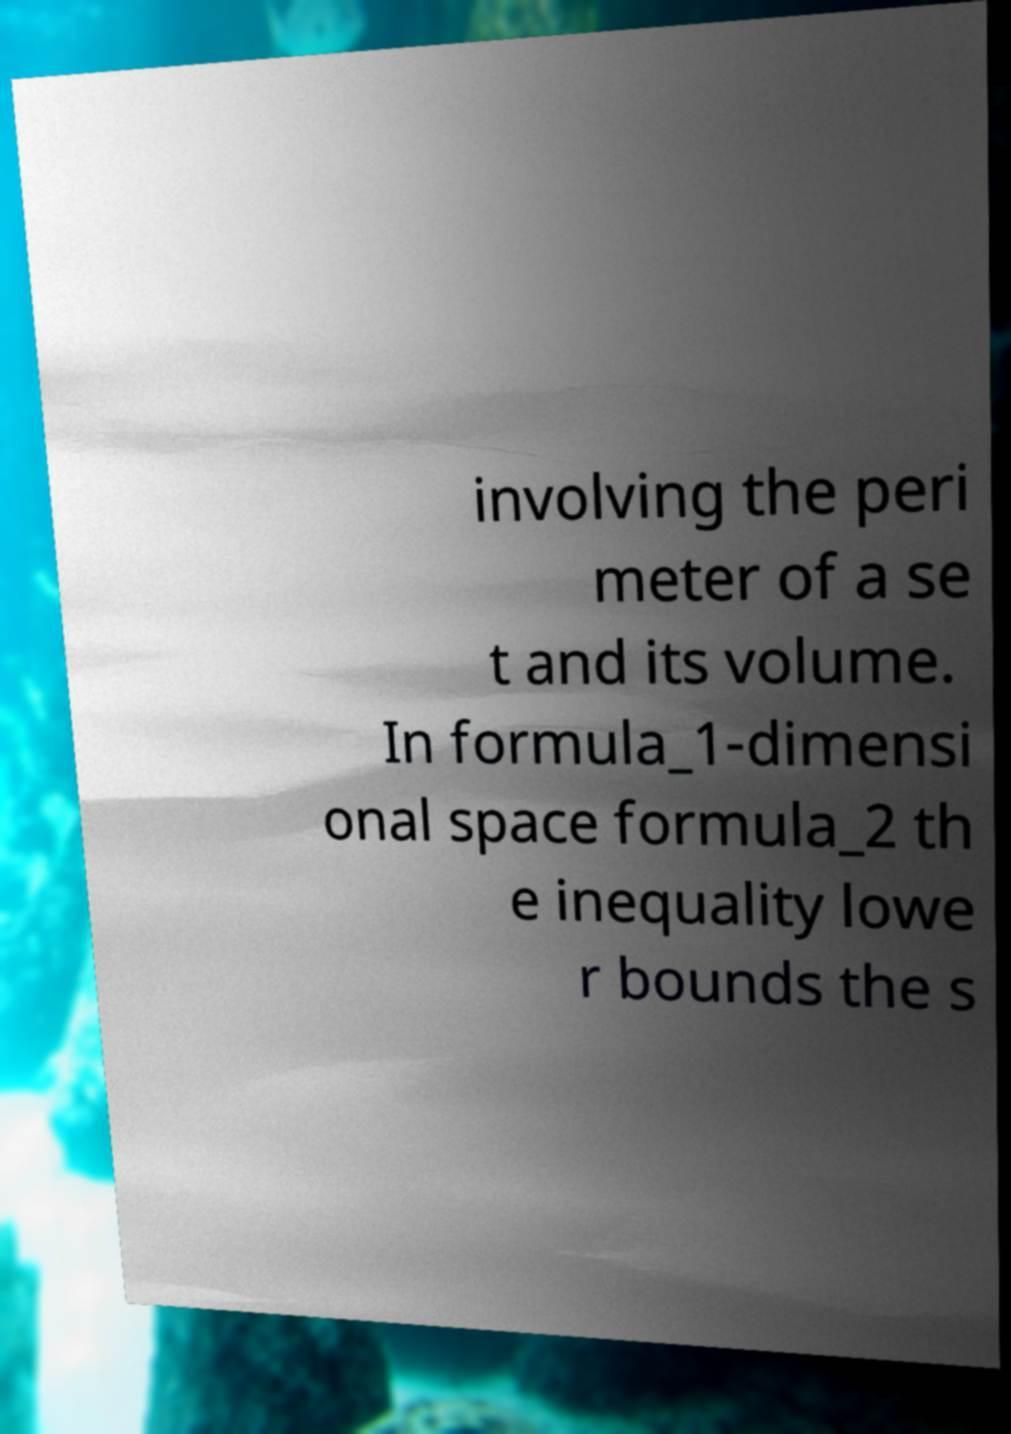What messages or text are displayed in this image? I need them in a readable, typed format. involving the peri meter of a se t and its volume. In formula_1-dimensi onal space formula_2 th e inequality lowe r bounds the s 